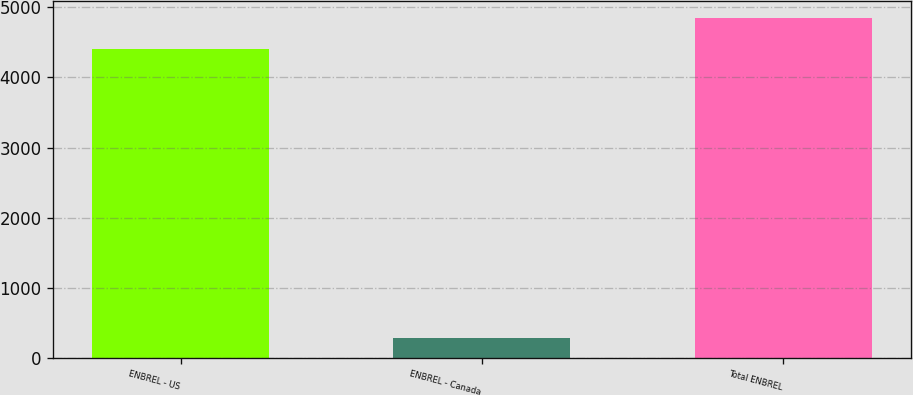Convert chart to OTSL. <chart><loc_0><loc_0><loc_500><loc_500><bar_chart><fcel>ENBREL - US<fcel>ENBREL - Canada<fcel>Total ENBREL<nl><fcel>4404<fcel>284<fcel>4844.4<nl></chart> 